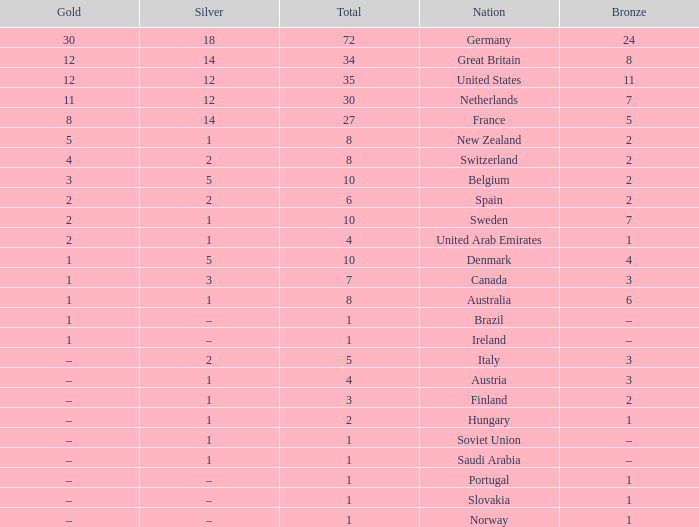What is Gold, when Bronze is 11? 12.0. 